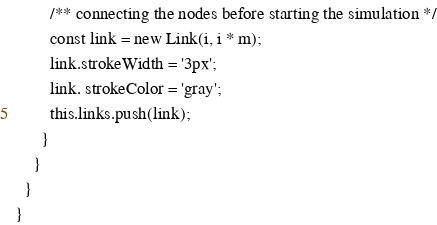<code> <loc_0><loc_0><loc_500><loc_500><_TypeScript_>        /** connecting the nodes before starting the simulation */
        const link = new Link(i, i * m);
        link.strokeWidth = '3px';
        link. strokeColor = 'gray';
        this.links.push(link);
      }
    }
  }
}
</code> 